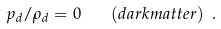Convert formula to latex. <formula><loc_0><loc_0><loc_500><loc_500>p _ { d } / \rho _ { d } = 0 \quad ( d a r k m a t t e r ) \ .</formula> 